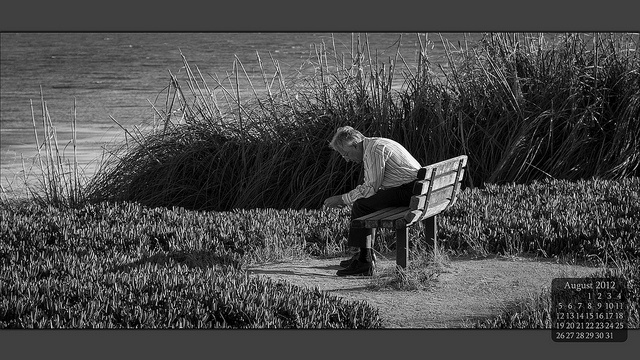Describe the objects in this image and their specific colors. I can see people in black, gray, darkgray, and lightgray tones and bench in black, darkgray, gray, and lightgray tones in this image. 